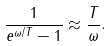Convert formula to latex. <formula><loc_0><loc_0><loc_500><loc_500>\frac { 1 } { e ^ { \omega / T } - 1 } \approx \frac { T } { \omega } .</formula> 